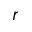<formula> <loc_0><loc_0><loc_500><loc_500>r</formula> 